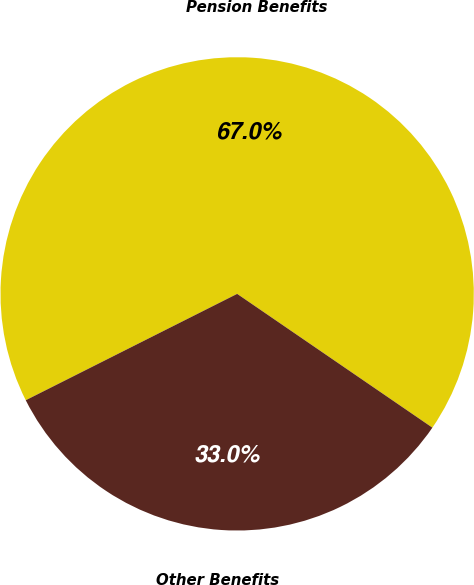Convert chart. <chart><loc_0><loc_0><loc_500><loc_500><pie_chart><fcel>Pension Benefits<fcel>Other Benefits<nl><fcel>66.98%<fcel>33.02%<nl></chart> 